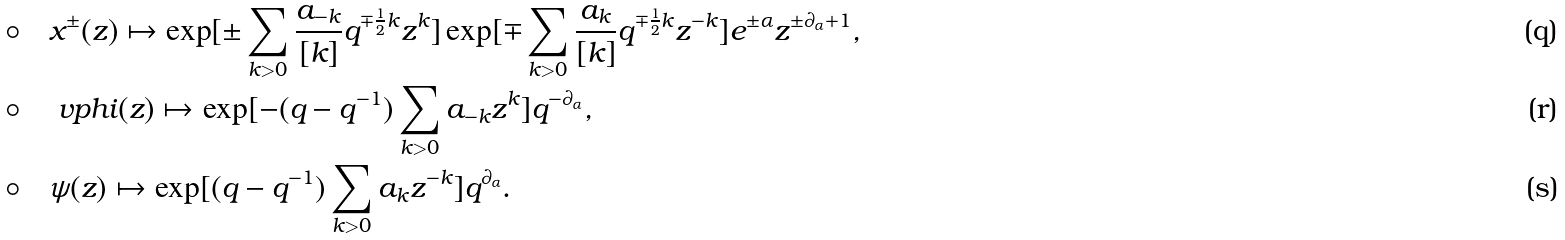Convert formula to latex. <formula><loc_0><loc_0><loc_500><loc_500>\circ & \quad x ^ { \pm } ( z ) \mapsto \exp [ \pm \sum _ { k > 0 } \frac { a _ { - k } } { [ k ] } q ^ { \mp \frac { 1 } { 2 } k } z ^ { k } ] \exp [ \mp \sum _ { k > 0 } \frac { a _ { k } } { [ k ] } q ^ { \mp \frac { 1 } { 2 } k } z ^ { - k } ] e ^ { \pm \alpha } z ^ { \pm \partial _ { \alpha } + 1 } , \\ \circ & \quad \ v p h i ( z ) \mapsto \exp [ - ( q - q ^ { - 1 } ) \sum _ { k > 0 } a _ { - k } z ^ { k } ] q ^ { - \partial _ { \alpha } } , \\ \circ & \quad \psi ( z ) \mapsto \exp [ ( q - q ^ { - 1 } ) \sum _ { k > 0 } a _ { k } z ^ { - k } ] q ^ { \partial _ { \alpha } } .</formula> 